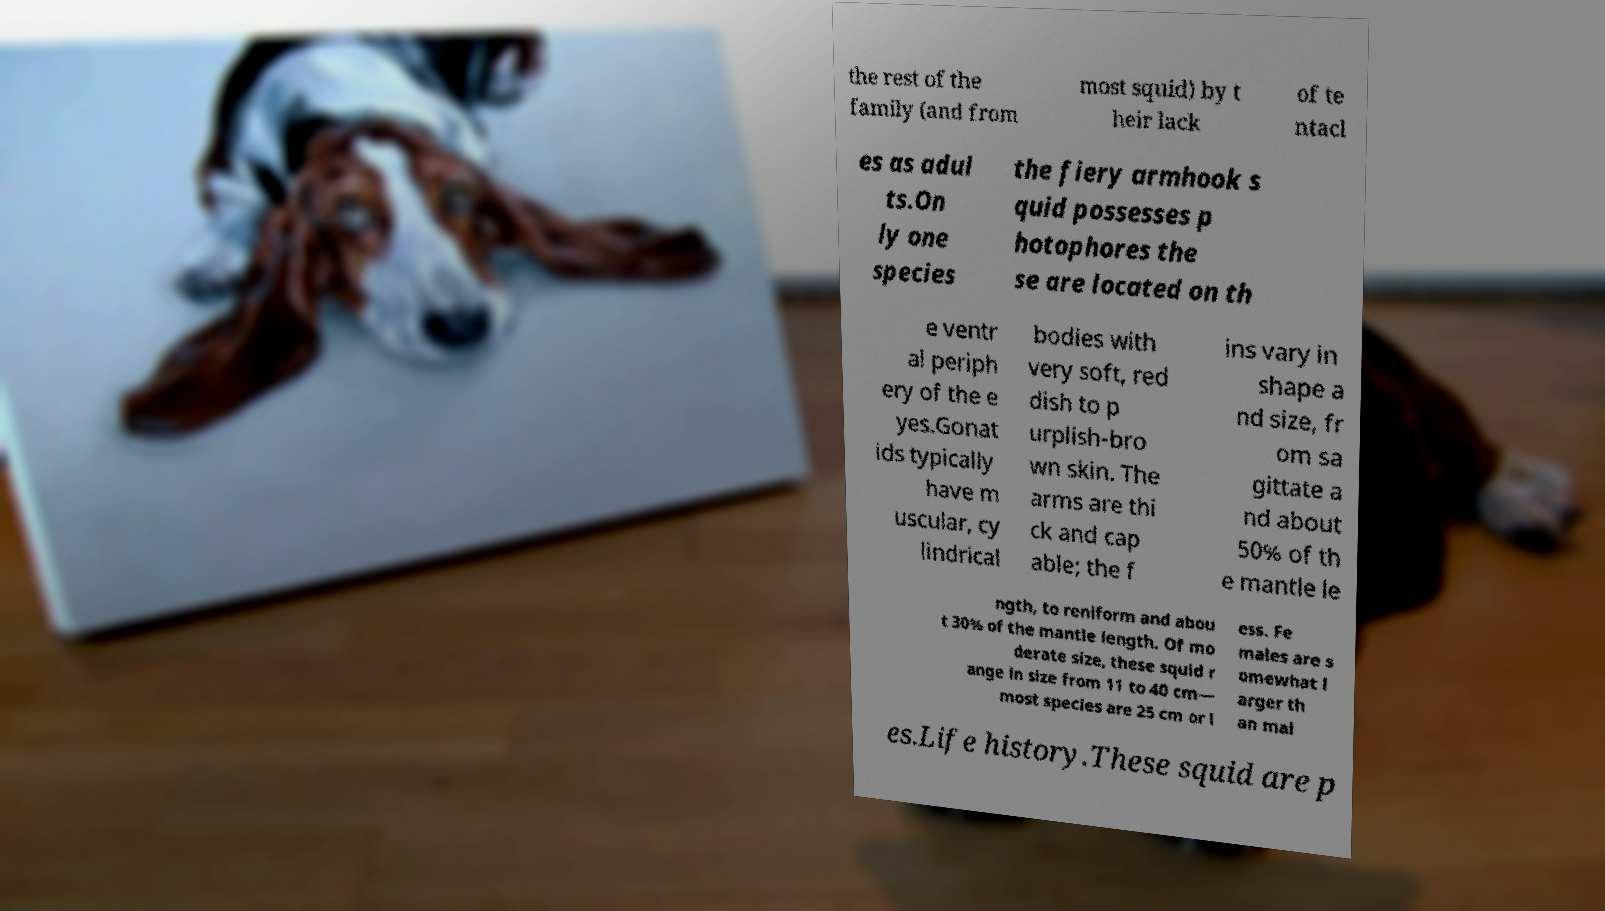For documentation purposes, I need the text within this image transcribed. Could you provide that? the rest of the family (and from most squid) by t heir lack of te ntacl es as adul ts.On ly one species the fiery armhook s quid possesses p hotophores the se are located on th e ventr al periph ery of the e yes.Gonat ids typically have m uscular, cy lindrical bodies with very soft, red dish to p urplish-bro wn skin. The arms are thi ck and cap able; the f ins vary in shape a nd size, fr om sa gittate a nd about 50% of th e mantle le ngth, to reniform and abou t 30% of the mantle length. Of mo derate size, these squid r ange in size from 11 to 40 cm— most species are 25 cm or l ess. Fe males are s omewhat l arger th an mal es.Life history.These squid are p 